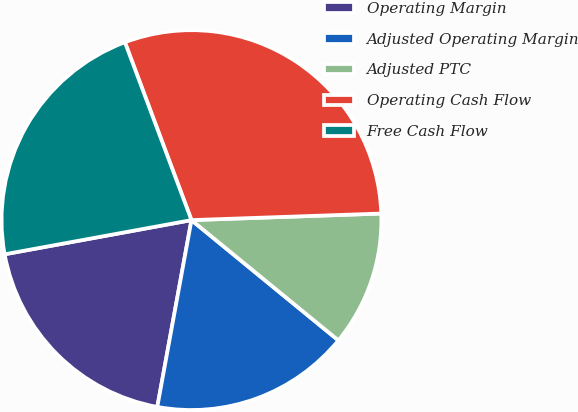<chart> <loc_0><loc_0><loc_500><loc_500><pie_chart><fcel>Operating Margin<fcel>Adjusted Operating Margin<fcel>Adjusted PTC<fcel>Operating Cash Flow<fcel>Free Cash Flow<nl><fcel>19.24%<fcel>16.96%<fcel>11.47%<fcel>30.15%<fcel>22.18%<nl></chart> 